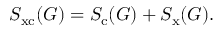Convert formula to latex. <formula><loc_0><loc_0><loc_500><loc_500>S _ { x c } ( G ) = S _ { c } ( G ) + S _ { x } ( G ) .</formula> 